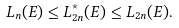<formula> <loc_0><loc_0><loc_500><loc_500>L _ { n } ( E ) \leq L ^ { * } _ { 2 n } ( E ) \leq L _ { 2 n } ( E ) .</formula> 